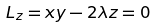<formula> <loc_0><loc_0><loc_500><loc_500>L _ { z } = x y - 2 \lambda z = 0</formula> 